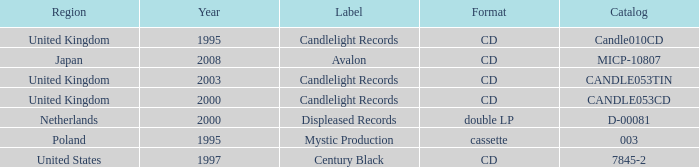What is Candlelight Records format? CD, CD, CD. 